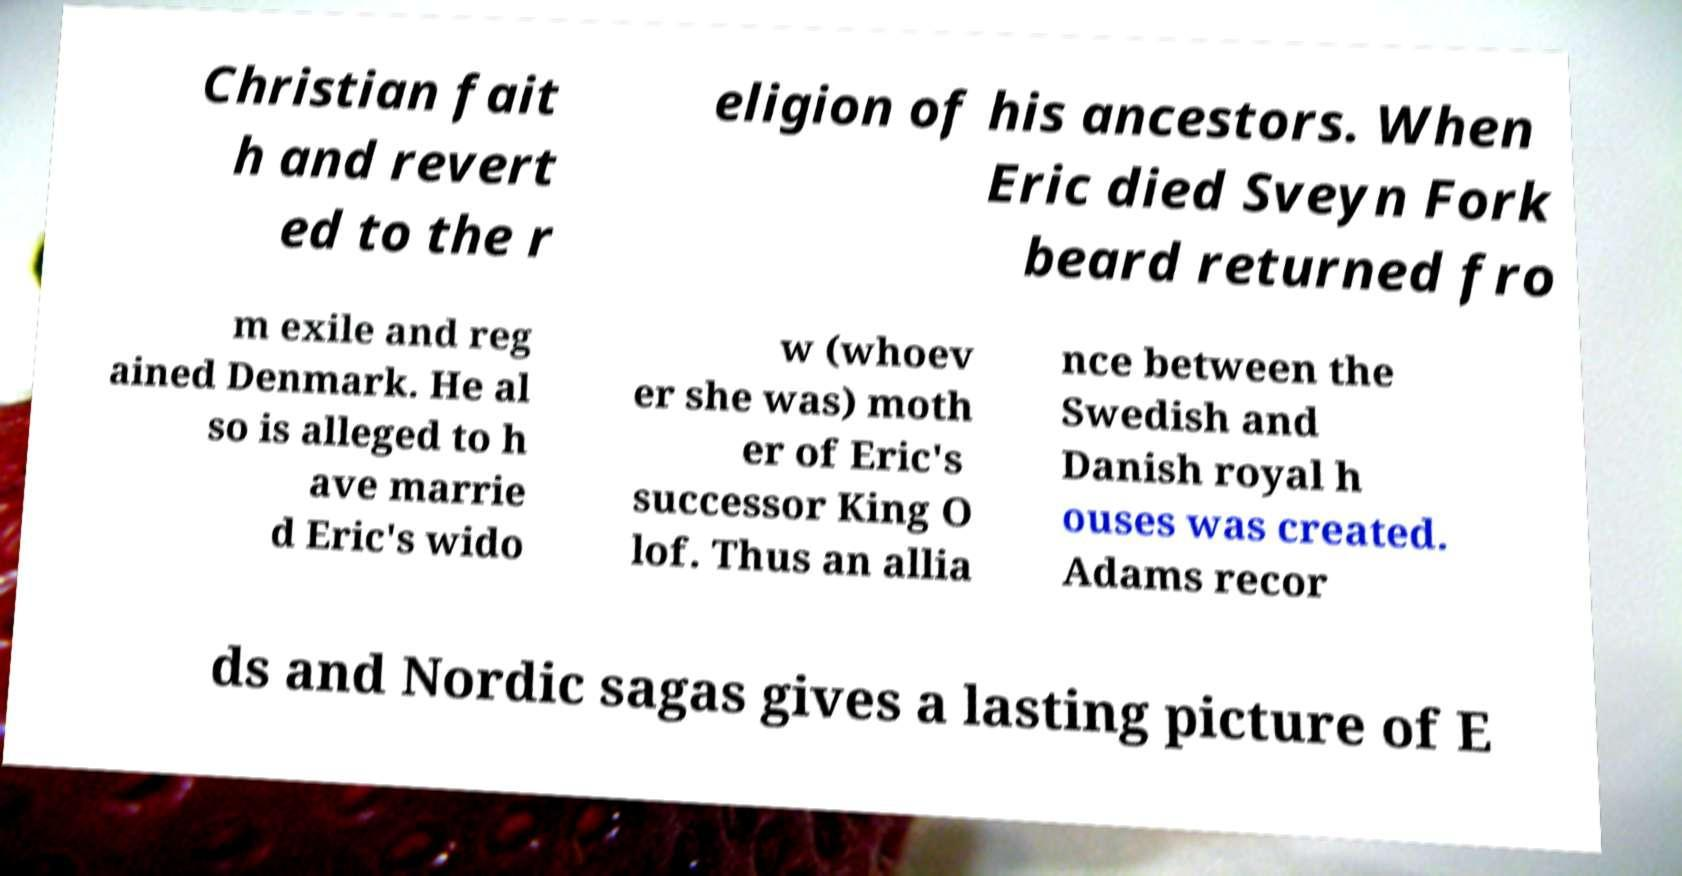Please read and relay the text visible in this image. What does it say? Christian fait h and revert ed to the r eligion of his ancestors. When Eric died Sveyn Fork beard returned fro m exile and reg ained Denmark. He al so is alleged to h ave marrie d Eric's wido w (whoev er she was) moth er of Eric's successor King O lof. Thus an allia nce between the Swedish and Danish royal h ouses was created. Adams recor ds and Nordic sagas gives a lasting picture of E 